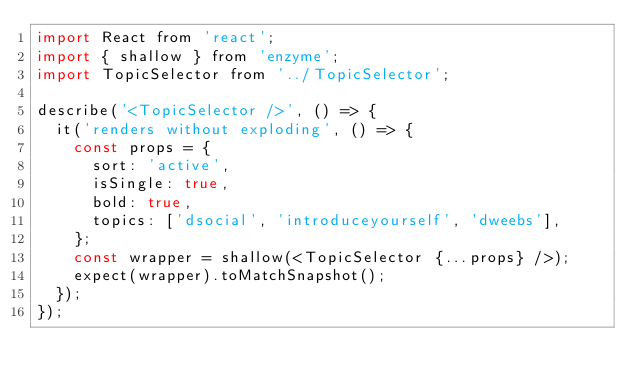Convert code to text. <code><loc_0><loc_0><loc_500><loc_500><_JavaScript_>import React from 'react';
import { shallow } from 'enzyme';
import TopicSelector from '../TopicSelector';

describe('<TopicSelector />', () => {
  it('renders without exploding', () => {
    const props = {
      sort: 'active',
      isSingle: true,
      bold: true,
      topics: ['dsocial', 'introduceyourself', 'dweebs'],
    };
    const wrapper = shallow(<TopicSelector {...props} />);
    expect(wrapper).toMatchSnapshot();
  });
});
</code> 